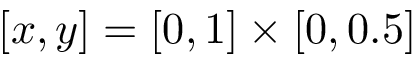<formula> <loc_0><loc_0><loc_500><loc_500>[ x , y ] = [ 0 , 1 ] \times [ 0 , 0 . 5 ]</formula> 